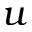<formula> <loc_0><loc_0><loc_500><loc_500>u</formula> 